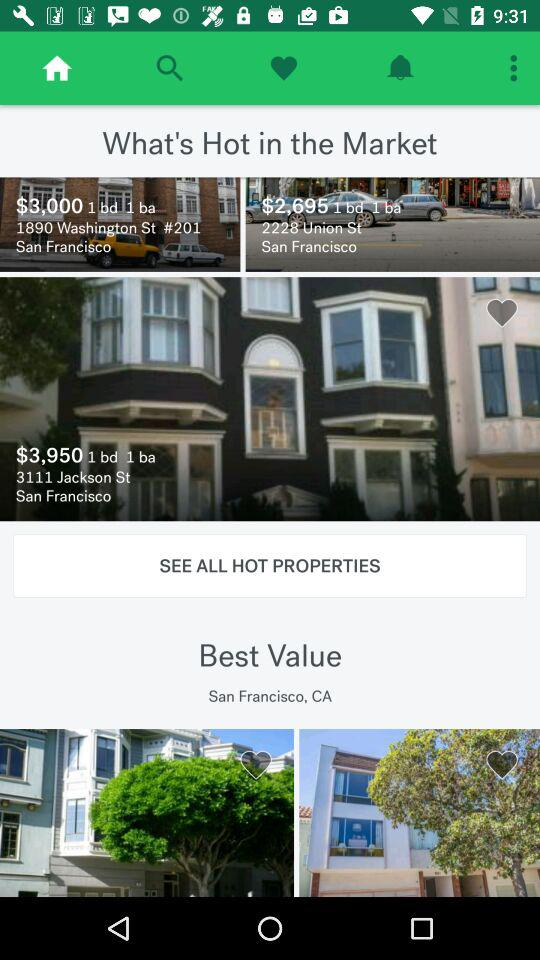What city is mentioned? The mentioned city is "San Francisco". 